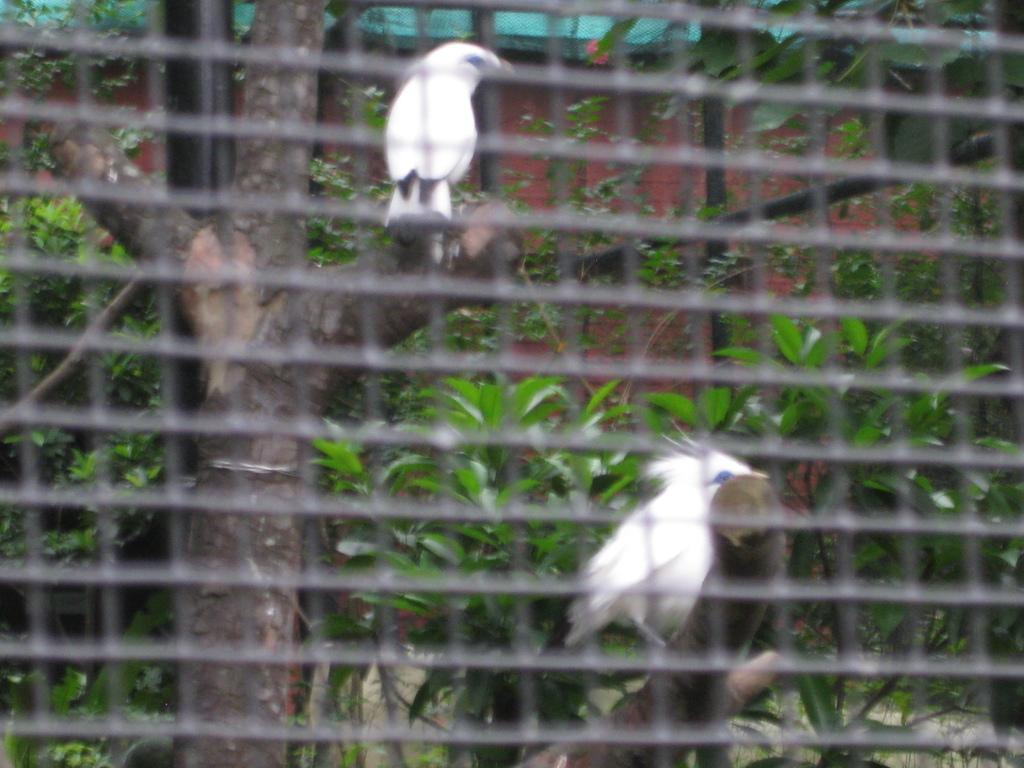What type of structure is present in the image? There is a mesh in the image. What type of living organisms can be seen in the image? There are birds on a tree in the image. What type of vegetation is present in the image? There are plants in the image. What type of architectural feature is present in the image? There is a wall in the image. What type of story is being told by the mesh in the image? There is no story being told by the mesh in the image; it is simply a structure. What type of ornament is hanging from the mesh in the image? There is no ornament hanging from the mesh in the image; only the mesh and the birds on the tree are present. 